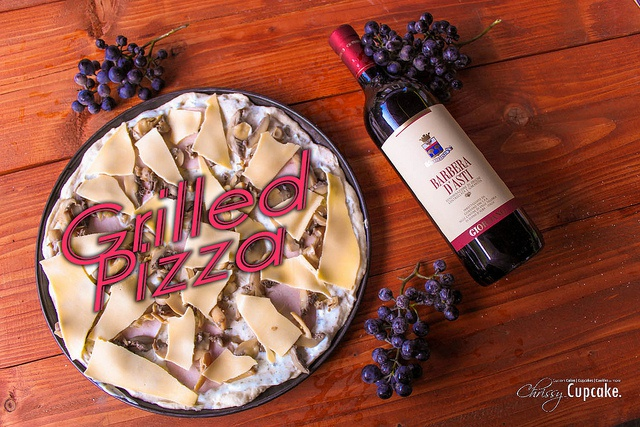Describe the objects in this image and their specific colors. I can see dining table in maroon, brown, black, lightgray, and salmon tones, pizza in brown, lightgray, tan, and gray tones, and bottle in brown, black, lightgray, maroon, and pink tones in this image. 